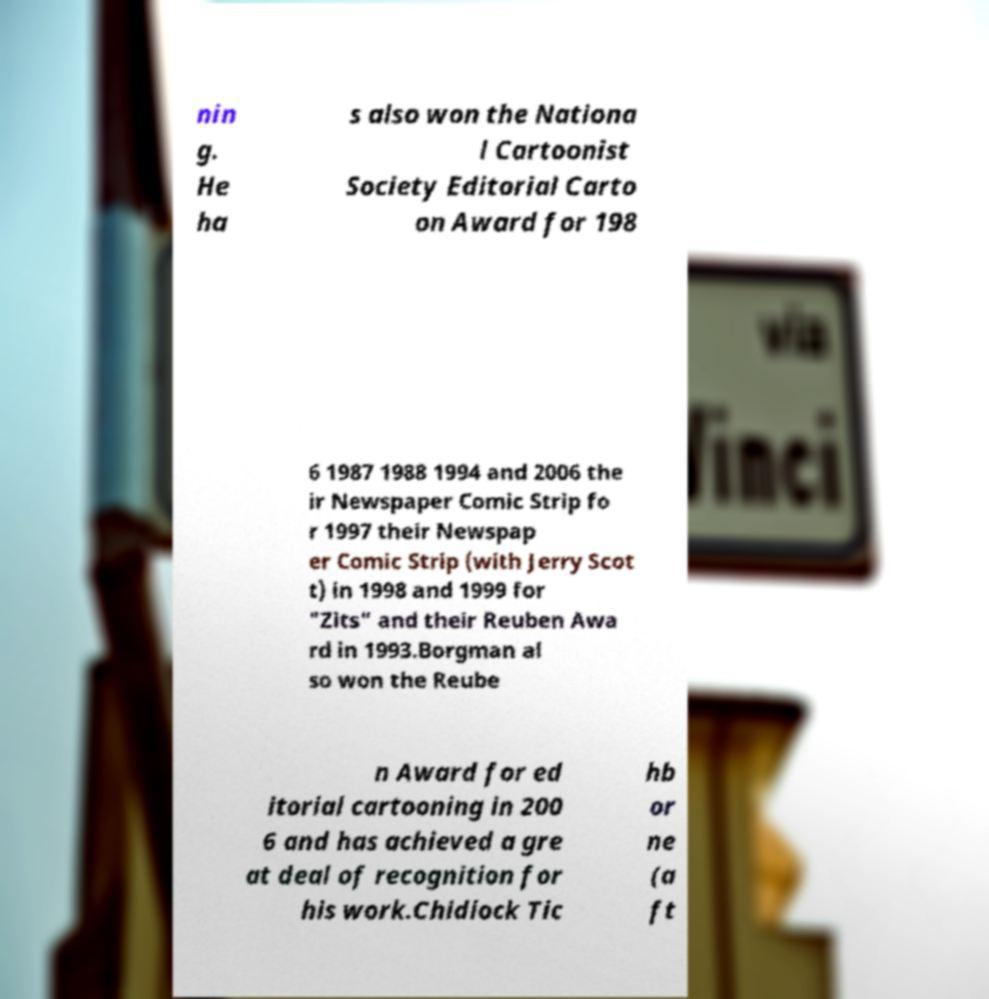What messages or text are displayed in this image? I need them in a readable, typed format. nin g. He ha s also won the Nationa l Cartoonist Society Editorial Carto on Award for 198 6 1987 1988 1994 and 2006 the ir Newspaper Comic Strip fo r 1997 their Newspap er Comic Strip (with Jerry Scot t) in 1998 and 1999 for "Zits" and their Reuben Awa rd in 1993.Borgman al so won the Reube n Award for ed itorial cartooning in 200 6 and has achieved a gre at deal of recognition for his work.Chidiock Tic hb or ne (a ft 